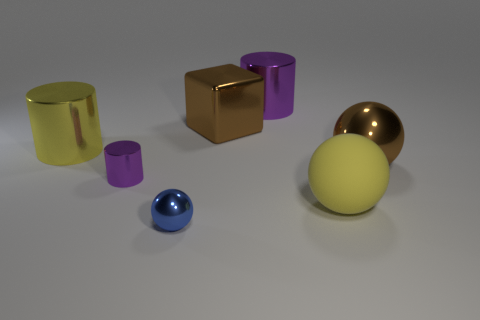Add 1 shiny spheres. How many objects exist? 8 Subtract all blocks. How many objects are left? 6 Add 3 large yellow metal balls. How many large yellow metal balls exist? 3 Subtract 1 brown balls. How many objects are left? 6 Subtract all tiny purple cylinders. Subtract all metallic cubes. How many objects are left? 5 Add 3 small metal cylinders. How many small metal cylinders are left? 4 